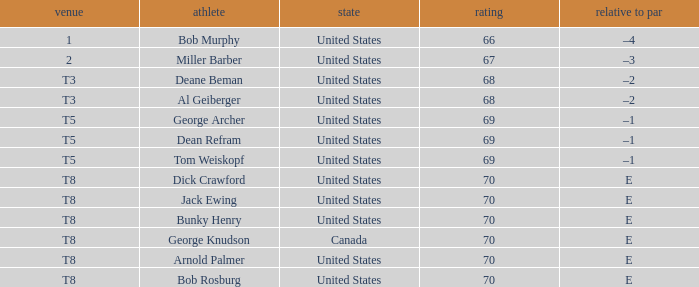When Bunky Henry placed t8, what was his To par? E. 